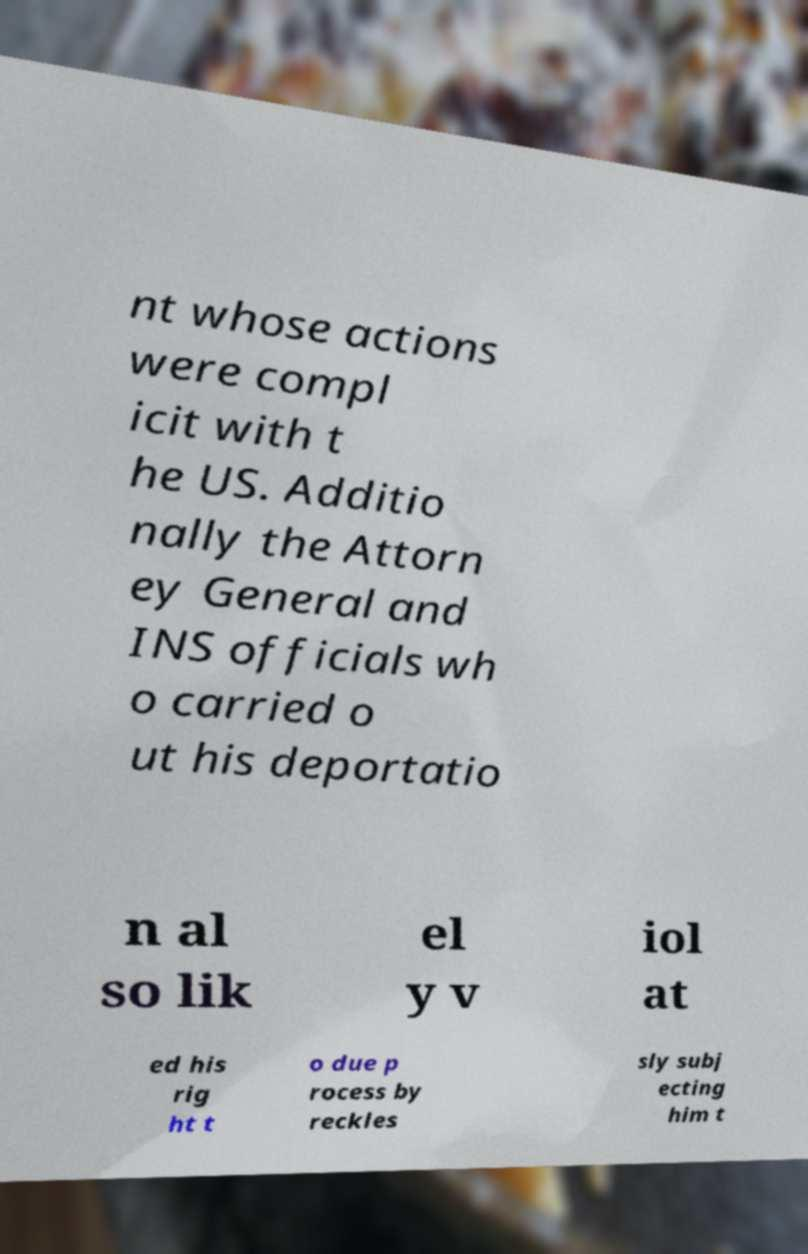I need the written content from this picture converted into text. Can you do that? nt whose actions were compl icit with t he US. Additio nally the Attorn ey General and INS officials wh o carried o ut his deportatio n al so lik el y v iol at ed his rig ht t o due p rocess by reckles sly subj ecting him t 